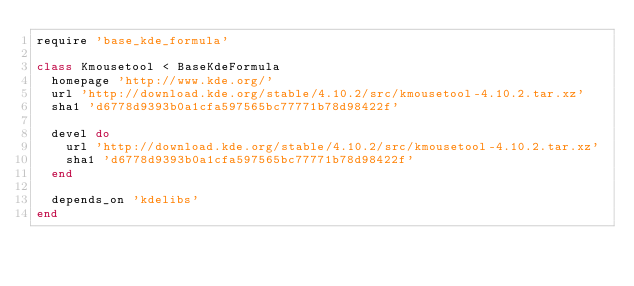Convert code to text. <code><loc_0><loc_0><loc_500><loc_500><_Ruby_>require 'base_kde_formula'

class Kmousetool < BaseKdeFormula
  homepage 'http://www.kde.org/'
  url 'http://download.kde.org/stable/4.10.2/src/kmousetool-4.10.2.tar.xz'
  sha1 'd6778d9393b0a1cfa597565bc77771b78d98422f'

  devel do
    url 'http://download.kde.org/stable/4.10.2/src/kmousetool-4.10.2.tar.xz'
    sha1 'd6778d9393b0a1cfa597565bc77771b78d98422f'
  end

  depends_on 'kdelibs'
end
</code> 